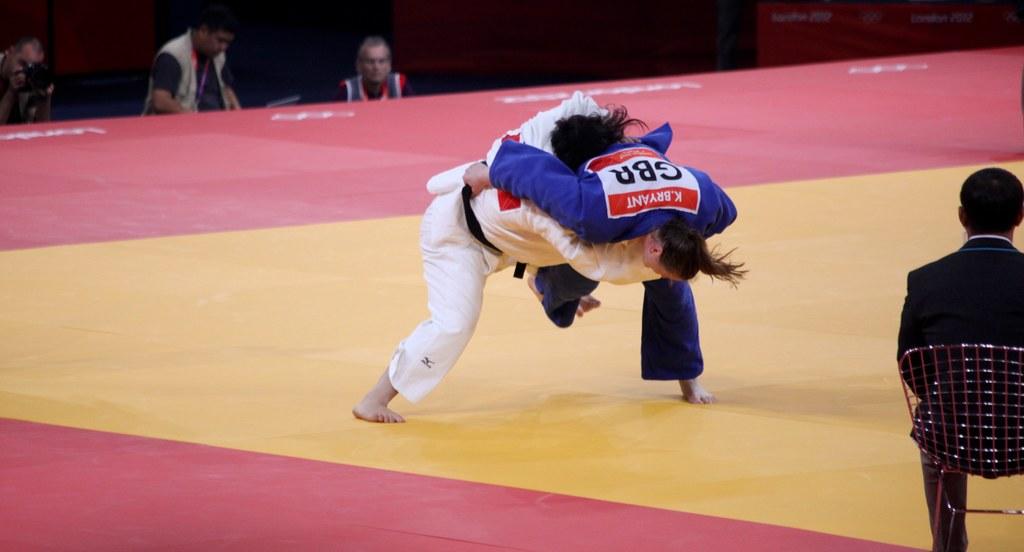What is the name on the back of the person wearing blue?
Provide a succinct answer. K. bryant. 